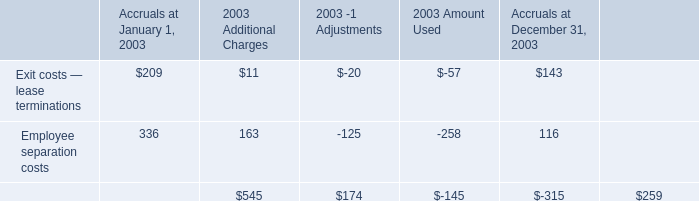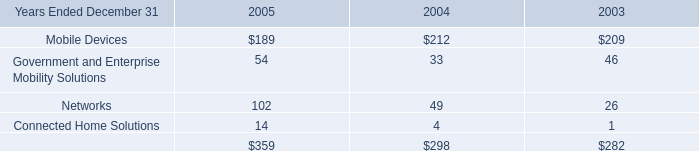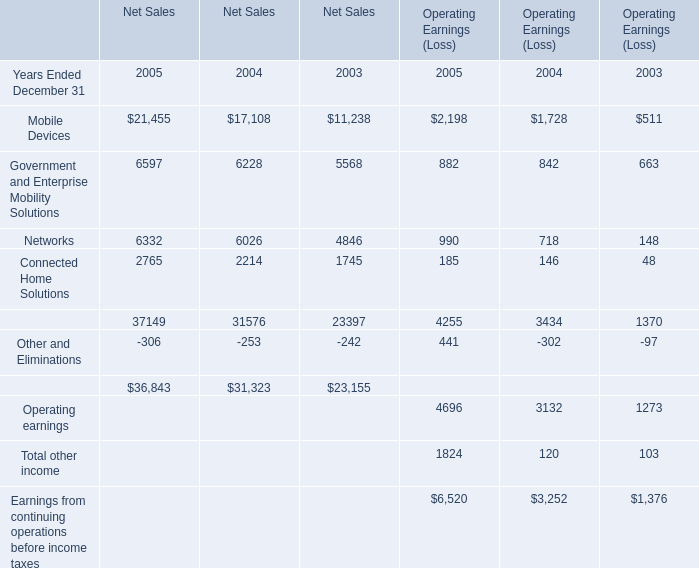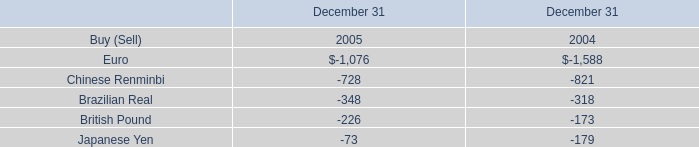What is the difference between the greatest Net Sales in 2004 and 2005？ 
Computations: (21455 - 17108)
Answer: 4347.0. 